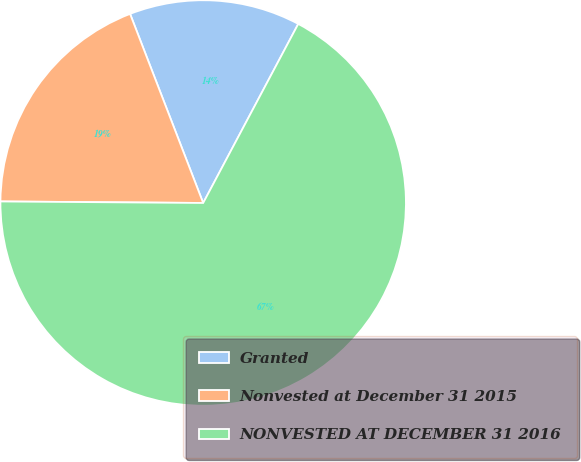Convert chart to OTSL. <chart><loc_0><loc_0><loc_500><loc_500><pie_chart><fcel>Granted<fcel>Nonvested at December 31 2015<fcel>NONVESTED AT DECEMBER 31 2016<nl><fcel>13.64%<fcel>19.01%<fcel>67.35%<nl></chart> 